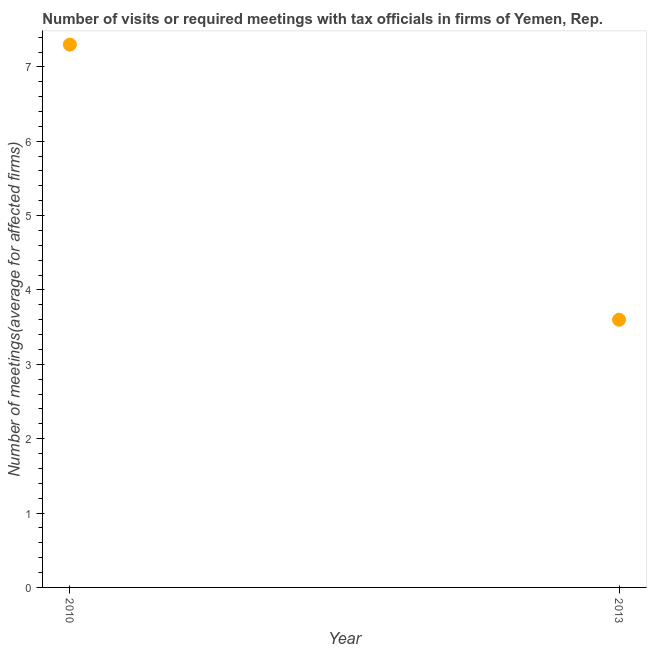Across all years, what is the maximum number of required meetings with tax officials?
Your answer should be compact. 7.3. Across all years, what is the minimum number of required meetings with tax officials?
Your answer should be compact. 3.6. In which year was the number of required meetings with tax officials minimum?
Give a very brief answer. 2013. What is the sum of the number of required meetings with tax officials?
Offer a terse response. 10.9. What is the difference between the number of required meetings with tax officials in 2010 and 2013?
Your response must be concise. 3.7. What is the average number of required meetings with tax officials per year?
Keep it short and to the point. 5.45. What is the median number of required meetings with tax officials?
Give a very brief answer. 5.45. Do a majority of the years between 2013 and 2010 (inclusive) have number of required meetings with tax officials greater than 0.8 ?
Make the answer very short. No. What is the ratio of the number of required meetings with tax officials in 2010 to that in 2013?
Make the answer very short. 2.03. Does the number of required meetings with tax officials monotonically increase over the years?
Give a very brief answer. No. Are the values on the major ticks of Y-axis written in scientific E-notation?
Your answer should be compact. No. Does the graph contain any zero values?
Offer a terse response. No. Does the graph contain grids?
Provide a succinct answer. No. What is the title of the graph?
Provide a short and direct response. Number of visits or required meetings with tax officials in firms of Yemen, Rep. What is the label or title of the Y-axis?
Keep it short and to the point. Number of meetings(average for affected firms). What is the Number of meetings(average for affected firms) in 2010?
Offer a very short reply. 7.3. What is the Number of meetings(average for affected firms) in 2013?
Your answer should be compact. 3.6. What is the difference between the Number of meetings(average for affected firms) in 2010 and 2013?
Give a very brief answer. 3.7. What is the ratio of the Number of meetings(average for affected firms) in 2010 to that in 2013?
Your answer should be very brief. 2.03. 